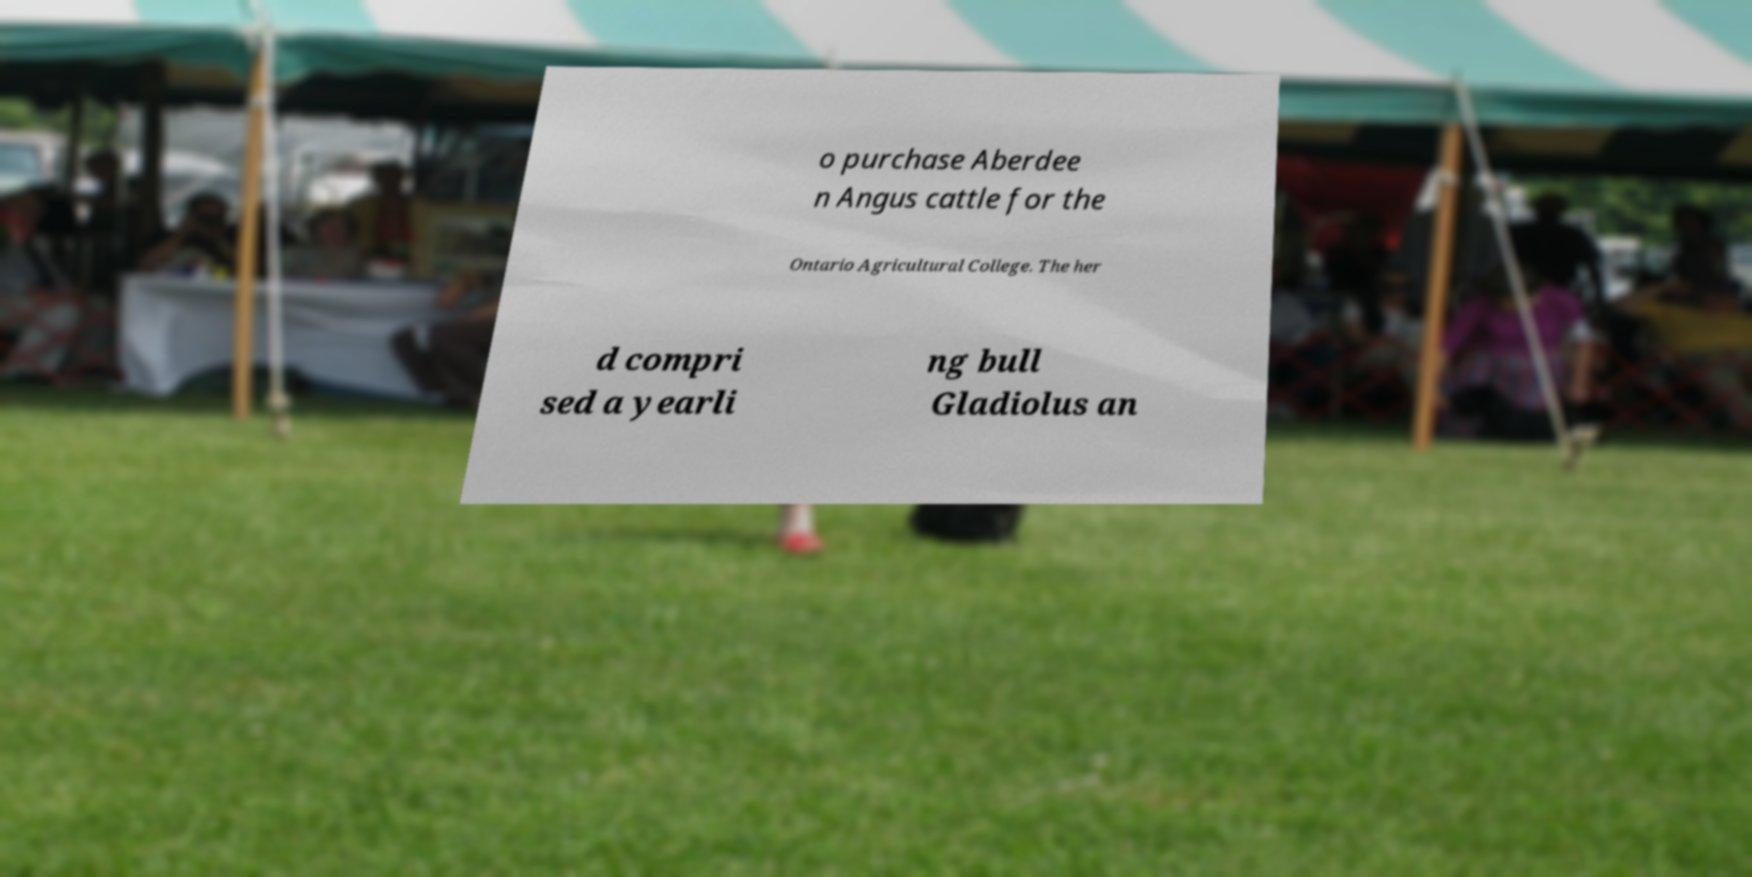Can you accurately transcribe the text from the provided image for me? o purchase Aberdee n Angus cattle for the Ontario Agricultural College. The her d compri sed a yearli ng bull Gladiolus an 